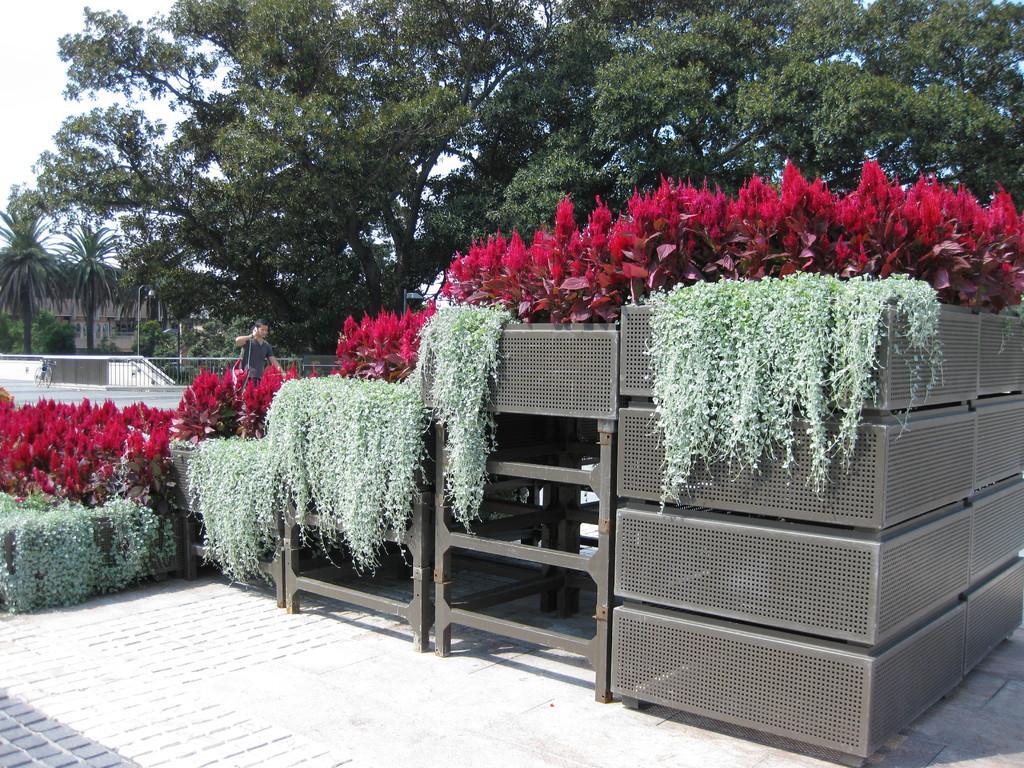Please provide a concise description of this image. In this image we can see planets on the metal thing. Behind the plant one man, fencing and trees are there. 